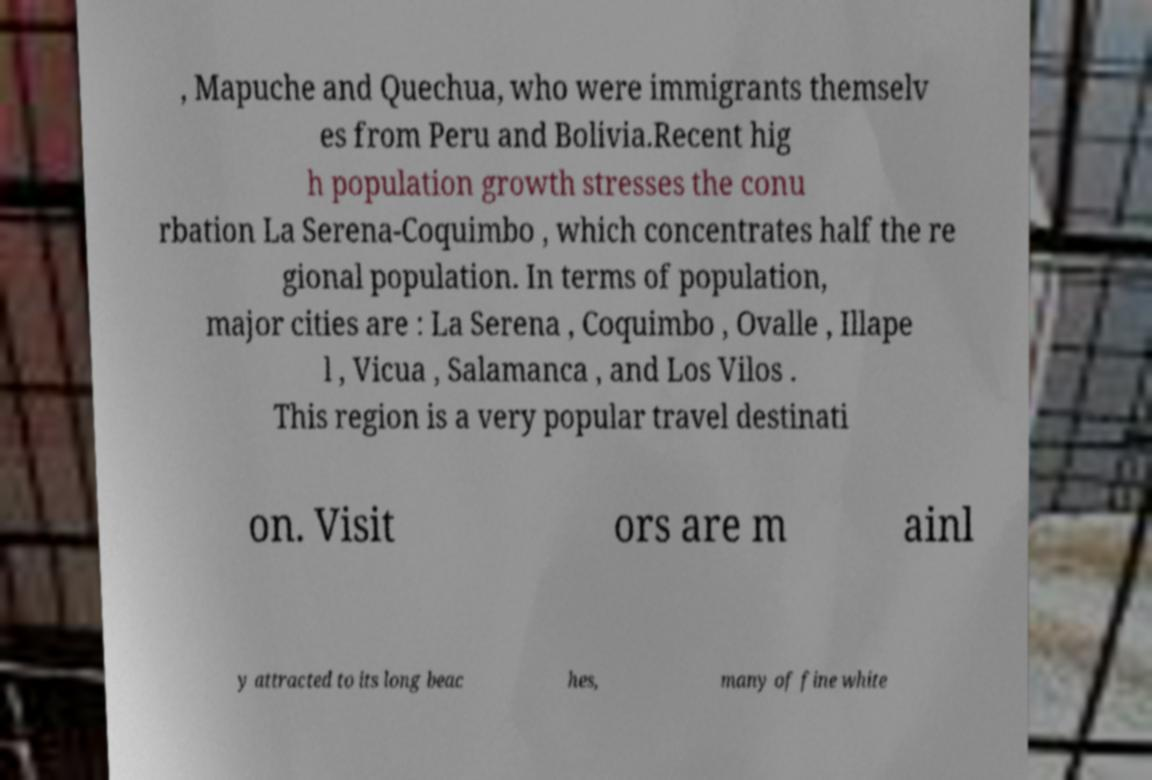Can you accurately transcribe the text from the provided image for me? , Mapuche and Quechua, who were immigrants themselv es from Peru and Bolivia.Recent hig h population growth stresses the conu rbation La Serena-Coquimbo , which concentrates half the re gional population. In terms of population, major cities are : La Serena , Coquimbo , Ovalle , Illape l , Vicua , Salamanca , and Los Vilos . This region is a very popular travel destinati on. Visit ors are m ainl y attracted to its long beac hes, many of fine white 